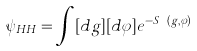Convert formula to latex. <formula><loc_0><loc_0><loc_500><loc_500>\psi _ { H H } = \int [ d g ] [ d \varphi ] e ^ { - S _ { E } ( g , \varphi ) }</formula> 